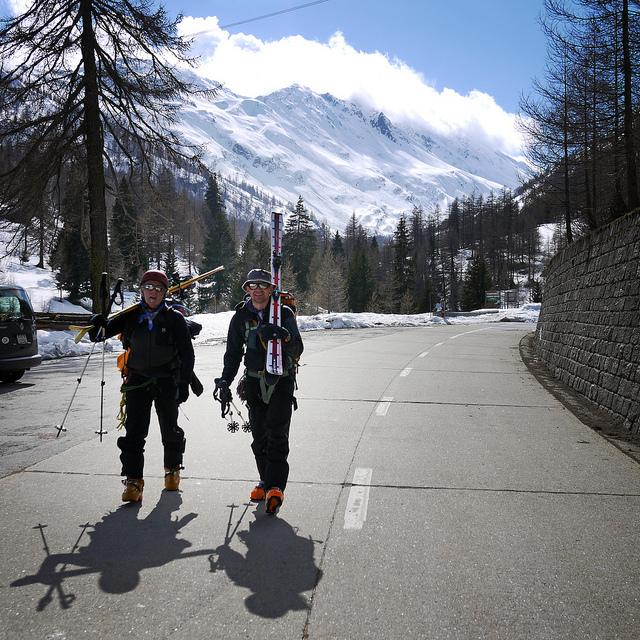The men here prefer to stop at which elevation to start their day of fun? higher 